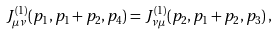Convert formula to latex. <formula><loc_0><loc_0><loc_500><loc_500>J _ { \mu \nu } ^ { ( 1 ) } ( p _ { 1 } , p _ { 1 } + p _ { 2 } , p _ { 4 } ) = J _ { \nu \mu } ^ { ( 1 ) } ( p _ { 2 } , p _ { 1 } + p _ { 2 } , p _ { 3 } ) \, ,</formula> 